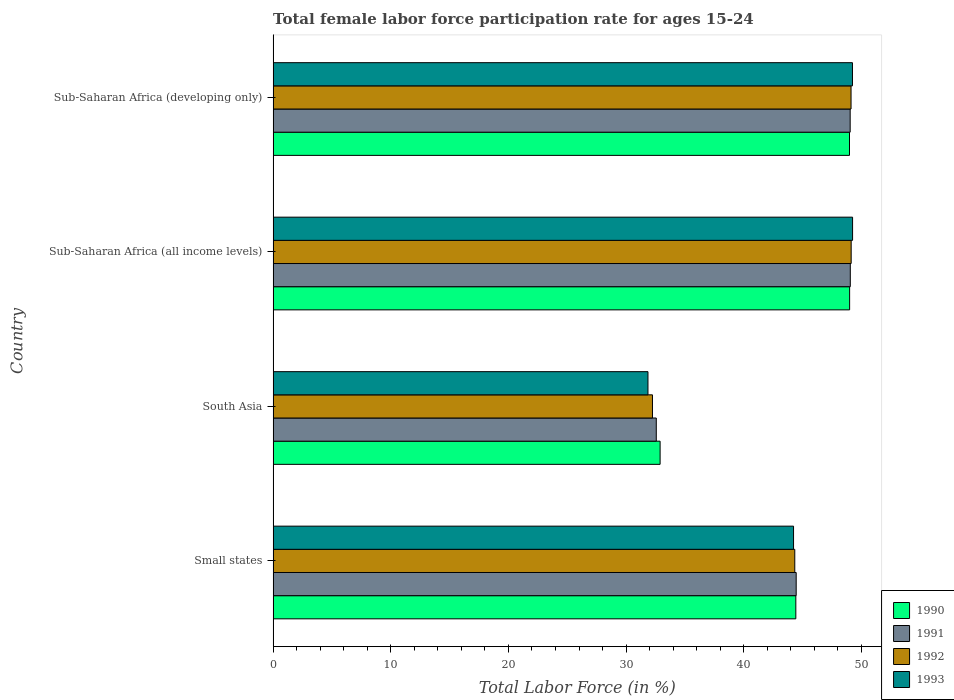How many different coloured bars are there?
Provide a succinct answer. 4. Are the number of bars on each tick of the Y-axis equal?
Your answer should be compact. Yes. How many bars are there on the 4th tick from the top?
Your response must be concise. 4. How many bars are there on the 2nd tick from the bottom?
Offer a very short reply. 4. What is the label of the 2nd group of bars from the top?
Provide a succinct answer. Sub-Saharan Africa (all income levels). What is the female labor force participation rate in 1990 in Sub-Saharan Africa (all income levels)?
Ensure brevity in your answer.  49. Across all countries, what is the maximum female labor force participation rate in 1993?
Your response must be concise. 49.25. Across all countries, what is the minimum female labor force participation rate in 1990?
Make the answer very short. 32.89. In which country was the female labor force participation rate in 1990 maximum?
Provide a succinct answer. Sub-Saharan Africa (all income levels). In which country was the female labor force participation rate in 1991 minimum?
Ensure brevity in your answer.  South Asia. What is the total female labor force participation rate in 1990 in the graph?
Your answer should be compact. 175.32. What is the difference between the female labor force participation rate in 1992 in South Asia and that in Sub-Saharan Africa (all income levels)?
Your response must be concise. -16.89. What is the difference between the female labor force participation rate in 1991 in Sub-Saharan Africa (developing only) and the female labor force participation rate in 1992 in Small states?
Make the answer very short. 4.71. What is the average female labor force participation rate in 1993 per country?
Offer a very short reply. 43.65. What is the difference between the female labor force participation rate in 1990 and female labor force participation rate in 1993 in Small states?
Your answer should be compact. 0.19. What is the ratio of the female labor force participation rate in 1991 in South Asia to that in Sub-Saharan Africa (all income levels)?
Your response must be concise. 0.66. Is the female labor force participation rate in 1993 in Sub-Saharan Africa (all income levels) less than that in Sub-Saharan Africa (developing only)?
Your response must be concise. No. Is the difference between the female labor force participation rate in 1990 in Small states and Sub-Saharan Africa (all income levels) greater than the difference between the female labor force participation rate in 1993 in Small states and Sub-Saharan Africa (all income levels)?
Make the answer very short. Yes. What is the difference between the highest and the second highest female labor force participation rate in 1990?
Offer a terse response. 0.01. What is the difference between the highest and the lowest female labor force participation rate in 1991?
Offer a terse response. 16.49. Is the sum of the female labor force participation rate in 1990 in Sub-Saharan Africa (all income levels) and Sub-Saharan Africa (developing only) greater than the maximum female labor force participation rate in 1991 across all countries?
Your answer should be compact. Yes. Is it the case that in every country, the sum of the female labor force participation rate in 1992 and female labor force participation rate in 1993 is greater than the sum of female labor force participation rate in 1991 and female labor force participation rate in 1990?
Provide a short and direct response. No. How many bars are there?
Ensure brevity in your answer.  16. Are the values on the major ticks of X-axis written in scientific E-notation?
Provide a short and direct response. No. How are the legend labels stacked?
Your answer should be compact. Vertical. What is the title of the graph?
Your answer should be very brief. Total female labor force participation rate for ages 15-24. Does "2009" appear as one of the legend labels in the graph?
Provide a short and direct response. No. What is the label or title of the X-axis?
Keep it short and to the point. Total Labor Force (in %). What is the Total Labor Force (in %) in 1990 in Small states?
Your response must be concise. 44.43. What is the Total Labor Force (in %) in 1991 in Small states?
Give a very brief answer. 44.46. What is the Total Labor Force (in %) of 1992 in Small states?
Provide a short and direct response. 44.34. What is the Total Labor Force (in %) of 1993 in Small states?
Give a very brief answer. 44.24. What is the Total Labor Force (in %) in 1990 in South Asia?
Offer a very short reply. 32.89. What is the Total Labor Force (in %) in 1991 in South Asia?
Keep it short and to the point. 32.57. What is the Total Labor Force (in %) in 1992 in South Asia?
Give a very brief answer. 32.24. What is the Total Labor Force (in %) in 1993 in South Asia?
Your answer should be very brief. 31.86. What is the Total Labor Force (in %) of 1990 in Sub-Saharan Africa (all income levels)?
Offer a very short reply. 49. What is the Total Labor Force (in %) of 1991 in Sub-Saharan Africa (all income levels)?
Provide a short and direct response. 49.06. What is the Total Labor Force (in %) in 1992 in Sub-Saharan Africa (all income levels)?
Your answer should be very brief. 49.13. What is the Total Labor Force (in %) of 1993 in Sub-Saharan Africa (all income levels)?
Give a very brief answer. 49.25. What is the Total Labor Force (in %) in 1990 in Sub-Saharan Africa (developing only)?
Your answer should be compact. 48.99. What is the Total Labor Force (in %) in 1991 in Sub-Saharan Africa (developing only)?
Keep it short and to the point. 49.05. What is the Total Labor Force (in %) in 1992 in Sub-Saharan Africa (developing only)?
Make the answer very short. 49.12. What is the Total Labor Force (in %) of 1993 in Sub-Saharan Africa (developing only)?
Your answer should be very brief. 49.24. Across all countries, what is the maximum Total Labor Force (in %) in 1990?
Your response must be concise. 49. Across all countries, what is the maximum Total Labor Force (in %) of 1991?
Your answer should be compact. 49.06. Across all countries, what is the maximum Total Labor Force (in %) of 1992?
Provide a short and direct response. 49.13. Across all countries, what is the maximum Total Labor Force (in %) in 1993?
Give a very brief answer. 49.25. Across all countries, what is the minimum Total Labor Force (in %) of 1990?
Make the answer very short. 32.89. Across all countries, what is the minimum Total Labor Force (in %) of 1991?
Provide a succinct answer. 32.57. Across all countries, what is the minimum Total Labor Force (in %) in 1992?
Give a very brief answer. 32.24. Across all countries, what is the minimum Total Labor Force (in %) of 1993?
Your answer should be compact. 31.86. What is the total Total Labor Force (in %) in 1990 in the graph?
Your answer should be compact. 175.32. What is the total Total Labor Force (in %) in 1991 in the graph?
Give a very brief answer. 175.14. What is the total Total Labor Force (in %) of 1992 in the graph?
Your answer should be compact. 174.84. What is the total Total Labor Force (in %) of 1993 in the graph?
Your response must be concise. 174.59. What is the difference between the Total Labor Force (in %) in 1990 in Small states and that in South Asia?
Give a very brief answer. 11.54. What is the difference between the Total Labor Force (in %) of 1991 in Small states and that in South Asia?
Offer a terse response. 11.89. What is the difference between the Total Labor Force (in %) in 1992 in Small states and that in South Asia?
Your answer should be compact. 12.1. What is the difference between the Total Labor Force (in %) in 1993 in Small states and that in South Asia?
Make the answer very short. 12.37. What is the difference between the Total Labor Force (in %) of 1990 in Small states and that in Sub-Saharan Africa (all income levels)?
Give a very brief answer. -4.57. What is the difference between the Total Labor Force (in %) in 1991 in Small states and that in Sub-Saharan Africa (all income levels)?
Your answer should be compact. -4.6. What is the difference between the Total Labor Force (in %) of 1992 in Small states and that in Sub-Saharan Africa (all income levels)?
Provide a short and direct response. -4.79. What is the difference between the Total Labor Force (in %) in 1993 in Small states and that in Sub-Saharan Africa (all income levels)?
Give a very brief answer. -5.02. What is the difference between the Total Labor Force (in %) of 1990 in Small states and that in Sub-Saharan Africa (developing only)?
Your answer should be compact. -4.56. What is the difference between the Total Labor Force (in %) of 1991 in Small states and that in Sub-Saharan Africa (developing only)?
Offer a very short reply. -4.59. What is the difference between the Total Labor Force (in %) in 1992 in Small states and that in Sub-Saharan Africa (developing only)?
Offer a very short reply. -4.78. What is the difference between the Total Labor Force (in %) in 1993 in Small states and that in Sub-Saharan Africa (developing only)?
Your answer should be very brief. -5.01. What is the difference between the Total Labor Force (in %) of 1990 in South Asia and that in Sub-Saharan Africa (all income levels)?
Keep it short and to the point. -16.11. What is the difference between the Total Labor Force (in %) of 1991 in South Asia and that in Sub-Saharan Africa (all income levels)?
Your answer should be compact. -16.49. What is the difference between the Total Labor Force (in %) in 1992 in South Asia and that in Sub-Saharan Africa (all income levels)?
Keep it short and to the point. -16.89. What is the difference between the Total Labor Force (in %) in 1993 in South Asia and that in Sub-Saharan Africa (all income levels)?
Offer a very short reply. -17.39. What is the difference between the Total Labor Force (in %) of 1990 in South Asia and that in Sub-Saharan Africa (developing only)?
Ensure brevity in your answer.  -16.1. What is the difference between the Total Labor Force (in %) of 1991 in South Asia and that in Sub-Saharan Africa (developing only)?
Provide a short and direct response. -16.48. What is the difference between the Total Labor Force (in %) of 1992 in South Asia and that in Sub-Saharan Africa (developing only)?
Ensure brevity in your answer.  -16.88. What is the difference between the Total Labor Force (in %) in 1993 in South Asia and that in Sub-Saharan Africa (developing only)?
Give a very brief answer. -17.38. What is the difference between the Total Labor Force (in %) of 1990 in Sub-Saharan Africa (all income levels) and that in Sub-Saharan Africa (developing only)?
Your answer should be compact. 0.01. What is the difference between the Total Labor Force (in %) in 1991 in Sub-Saharan Africa (all income levels) and that in Sub-Saharan Africa (developing only)?
Keep it short and to the point. 0.01. What is the difference between the Total Labor Force (in %) in 1992 in Sub-Saharan Africa (all income levels) and that in Sub-Saharan Africa (developing only)?
Provide a succinct answer. 0.01. What is the difference between the Total Labor Force (in %) of 1993 in Sub-Saharan Africa (all income levels) and that in Sub-Saharan Africa (developing only)?
Provide a short and direct response. 0.01. What is the difference between the Total Labor Force (in %) in 1990 in Small states and the Total Labor Force (in %) in 1991 in South Asia?
Provide a succinct answer. 11.86. What is the difference between the Total Labor Force (in %) of 1990 in Small states and the Total Labor Force (in %) of 1992 in South Asia?
Your answer should be compact. 12.19. What is the difference between the Total Labor Force (in %) of 1990 in Small states and the Total Labor Force (in %) of 1993 in South Asia?
Provide a succinct answer. 12.57. What is the difference between the Total Labor Force (in %) in 1991 in Small states and the Total Labor Force (in %) in 1992 in South Asia?
Provide a succinct answer. 12.22. What is the difference between the Total Labor Force (in %) in 1991 in Small states and the Total Labor Force (in %) in 1993 in South Asia?
Provide a short and direct response. 12.6. What is the difference between the Total Labor Force (in %) in 1992 in Small states and the Total Labor Force (in %) in 1993 in South Asia?
Offer a very short reply. 12.48. What is the difference between the Total Labor Force (in %) in 1990 in Small states and the Total Labor Force (in %) in 1991 in Sub-Saharan Africa (all income levels)?
Provide a succinct answer. -4.63. What is the difference between the Total Labor Force (in %) in 1990 in Small states and the Total Labor Force (in %) in 1992 in Sub-Saharan Africa (all income levels)?
Give a very brief answer. -4.7. What is the difference between the Total Labor Force (in %) in 1990 in Small states and the Total Labor Force (in %) in 1993 in Sub-Saharan Africa (all income levels)?
Your answer should be compact. -4.82. What is the difference between the Total Labor Force (in %) in 1991 in Small states and the Total Labor Force (in %) in 1992 in Sub-Saharan Africa (all income levels)?
Give a very brief answer. -4.67. What is the difference between the Total Labor Force (in %) of 1991 in Small states and the Total Labor Force (in %) of 1993 in Sub-Saharan Africa (all income levels)?
Give a very brief answer. -4.79. What is the difference between the Total Labor Force (in %) of 1992 in Small states and the Total Labor Force (in %) of 1993 in Sub-Saharan Africa (all income levels)?
Give a very brief answer. -4.91. What is the difference between the Total Labor Force (in %) of 1990 in Small states and the Total Labor Force (in %) of 1991 in Sub-Saharan Africa (developing only)?
Ensure brevity in your answer.  -4.62. What is the difference between the Total Labor Force (in %) of 1990 in Small states and the Total Labor Force (in %) of 1992 in Sub-Saharan Africa (developing only)?
Your response must be concise. -4.69. What is the difference between the Total Labor Force (in %) of 1990 in Small states and the Total Labor Force (in %) of 1993 in Sub-Saharan Africa (developing only)?
Offer a very short reply. -4.81. What is the difference between the Total Labor Force (in %) of 1991 in Small states and the Total Labor Force (in %) of 1992 in Sub-Saharan Africa (developing only)?
Keep it short and to the point. -4.66. What is the difference between the Total Labor Force (in %) in 1991 in Small states and the Total Labor Force (in %) in 1993 in Sub-Saharan Africa (developing only)?
Provide a succinct answer. -4.78. What is the difference between the Total Labor Force (in %) in 1992 in Small states and the Total Labor Force (in %) in 1993 in Sub-Saharan Africa (developing only)?
Give a very brief answer. -4.9. What is the difference between the Total Labor Force (in %) in 1990 in South Asia and the Total Labor Force (in %) in 1991 in Sub-Saharan Africa (all income levels)?
Your answer should be very brief. -16.17. What is the difference between the Total Labor Force (in %) of 1990 in South Asia and the Total Labor Force (in %) of 1992 in Sub-Saharan Africa (all income levels)?
Your answer should be compact. -16.24. What is the difference between the Total Labor Force (in %) in 1990 in South Asia and the Total Labor Force (in %) in 1993 in Sub-Saharan Africa (all income levels)?
Your answer should be very brief. -16.36. What is the difference between the Total Labor Force (in %) of 1991 in South Asia and the Total Labor Force (in %) of 1992 in Sub-Saharan Africa (all income levels)?
Provide a short and direct response. -16.56. What is the difference between the Total Labor Force (in %) in 1991 in South Asia and the Total Labor Force (in %) in 1993 in Sub-Saharan Africa (all income levels)?
Give a very brief answer. -16.68. What is the difference between the Total Labor Force (in %) in 1992 in South Asia and the Total Labor Force (in %) in 1993 in Sub-Saharan Africa (all income levels)?
Provide a succinct answer. -17.01. What is the difference between the Total Labor Force (in %) in 1990 in South Asia and the Total Labor Force (in %) in 1991 in Sub-Saharan Africa (developing only)?
Ensure brevity in your answer.  -16.16. What is the difference between the Total Labor Force (in %) of 1990 in South Asia and the Total Labor Force (in %) of 1992 in Sub-Saharan Africa (developing only)?
Give a very brief answer. -16.23. What is the difference between the Total Labor Force (in %) in 1990 in South Asia and the Total Labor Force (in %) in 1993 in Sub-Saharan Africa (developing only)?
Make the answer very short. -16.35. What is the difference between the Total Labor Force (in %) of 1991 in South Asia and the Total Labor Force (in %) of 1992 in Sub-Saharan Africa (developing only)?
Your answer should be compact. -16.55. What is the difference between the Total Labor Force (in %) in 1991 in South Asia and the Total Labor Force (in %) in 1993 in Sub-Saharan Africa (developing only)?
Your response must be concise. -16.68. What is the difference between the Total Labor Force (in %) of 1992 in South Asia and the Total Labor Force (in %) of 1993 in Sub-Saharan Africa (developing only)?
Make the answer very short. -17. What is the difference between the Total Labor Force (in %) in 1990 in Sub-Saharan Africa (all income levels) and the Total Labor Force (in %) in 1991 in Sub-Saharan Africa (developing only)?
Keep it short and to the point. -0.05. What is the difference between the Total Labor Force (in %) of 1990 in Sub-Saharan Africa (all income levels) and the Total Labor Force (in %) of 1992 in Sub-Saharan Africa (developing only)?
Keep it short and to the point. -0.12. What is the difference between the Total Labor Force (in %) of 1990 in Sub-Saharan Africa (all income levels) and the Total Labor Force (in %) of 1993 in Sub-Saharan Africa (developing only)?
Provide a succinct answer. -0.24. What is the difference between the Total Labor Force (in %) of 1991 in Sub-Saharan Africa (all income levels) and the Total Labor Force (in %) of 1992 in Sub-Saharan Africa (developing only)?
Offer a terse response. -0.06. What is the difference between the Total Labor Force (in %) of 1991 in Sub-Saharan Africa (all income levels) and the Total Labor Force (in %) of 1993 in Sub-Saharan Africa (developing only)?
Offer a terse response. -0.18. What is the difference between the Total Labor Force (in %) in 1992 in Sub-Saharan Africa (all income levels) and the Total Labor Force (in %) in 1993 in Sub-Saharan Africa (developing only)?
Give a very brief answer. -0.11. What is the average Total Labor Force (in %) in 1990 per country?
Make the answer very short. 43.83. What is the average Total Labor Force (in %) of 1991 per country?
Provide a short and direct response. 43.78. What is the average Total Labor Force (in %) of 1992 per country?
Make the answer very short. 43.71. What is the average Total Labor Force (in %) of 1993 per country?
Ensure brevity in your answer.  43.65. What is the difference between the Total Labor Force (in %) in 1990 and Total Labor Force (in %) in 1991 in Small states?
Provide a short and direct response. -0.03. What is the difference between the Total Labor Force (in %) of 1990 and Total Labor Force (in %) of 1992 in Small states?
Give a very brief answer. 0.09. What is the difference between the Total Labor Force (in %) in 1990 and Total Labor Force (in %) in 1993 in Small states?
Keep it short and to the point. 0.19. What is the difference between the Total Labor Force (in %) in 1991 and Total Labor Force (in %) in 1992 in Small states?
Provide a succinct answer. 0.12. What is the difference between the Total Labor Force (in %) in 1991 and Total Labor Force (in %) in 1993 in Small states?
Your answer should be compact. 0.22. What is the difference between the Total Labor Force (in %) of 1992 and Total Labor Force (in %) of 1993 in Small states?
Your answer should be very brief. 0.1. What is the difference between the Total Labor Force (in %) of 1990 and Total Labor Force (in %) of 1991 in South Asia?
Ensure brevity in your answer.  0.32. What is the difference between the Total Labor Force (in %) of 1990 and Total Labor Force (in %) of 1992 in South Asia?
Provide a short and direct response. 0.65. What is the difference between the Total Labor Force (in %) in 1990 and Total Labor Force (in %) in 1993 in South Asia?
Your response must be concise. 1.03. What is the difference between the Total Labor Force (in %) of 1991 and Total Labor Force (in %) of 1992 in South Asia?
Your response must be concise. 0.32. What is the difference between the Total Labor Force (in %) in 1991 and Total Labor Force (in %) in 1993 in South Asia?
Your answer should be compact. 0.71. What is the difference between the Total Labor Force (in %) in 1992 and Total Labor Force (in %) in 1993 in South Asia?
Your answer should be very brief. 0.38. What is the difference between the Total Labor Force (in %) in 1990 and Total Labor Force (in %) in 1991 in Sub-Saharan Africa (all income levels)?
Provide a short and direct response. -0.06. What is the difference between the Total Labor Force (in %) in 1990 and Total Labor Force (in %) in 1992 in Sub-Saharan Africa (all income levels)?
Your answer should be very brief. -0.13. What is the difference between the Total Labor Force (in %) in 1990 and Total Labor Force (in %) in 1993 in Sub-Saharan Africa (all income levels)?
Keep it short and to the point. -0.25. What is the difference between the Total Labor Force (in %) of 1991 and Total Labor Force (in %) of 1992 in Sub-Saharan Africa (all income levels)?
Provide a succinct answer. -0.07. What is the difference between the Total Labor Force (in %) of 1991 and Total Labor Force (in %) of 1993 in Sub-Saharan Africa (all income levels)?
Provide a short and direct response. -0.19. What is the difference between the Total Labor Force (in %) in 1992 and Total Labor Force (in %) in 1993 in Sub-Saharan Africa (all income levels)?
Your response must be concise. -0.12. What is the difference between the Total Labor Force (in %) of 1990 and Total Labor Force (in %) of 1991 in Sub-Saharan Africa (developing only)?
Ensure brevity in your answer.  -0.06. What is the difference between the Total Labor Force (in %) of 1990 and Total Labor Force (in %) of 1992 in Sub-Saharan Africa (developing only)?
Keep it short and to the point. -0.13. What is the difference between the Total Labor Force (in %) in 1990 and Total Labor Force (in %) in 1993 in Sub-Saharan Africa (developing only)?
Make the answer very short. -0.25. What is the difference between the Total Labor Force (in %) in 1991 and Total Labor Force (in %) in 1992 in Sub-Saharan Africa (developing only)?
Your response must be concise. -0.07. What is the difference between the Total Labor Force (in %) in 1991 and Total Labor Force (in %) in 1993 in Sub-Saharan Africa (developing only)?
Ensure brevity in your answer.  -0.2. What is the difference between the Total Labor Force (in %) of 1992 and Total Labor Force (in %) of 1993 in Sub-Saharan Africa (developing only)?
Provide a succinct answer. -0.12. What is the ratio of the Total Labor Force (in %) in 1990 in Small states to that in South Asia?
Provide a short and direct response. 1.35. What is the ratio of the Total Labor Force (in %) of 1991 in Small states to that in South Asia?
Offer a very short reply. 1.37. What is the ratio of the Total Labor Force (in %) in 1992 in Small states to that in South Asia?
Ensure brevity in your answer.  1.38. What is the ratio of the Total Labor Force (in %) of 1993 in Small states to that in South Asia?
Make the answer very short. 1.39. What is the ratio of the Total Labor Force (in %) of 1990 in Small states to that in Sub-Saharan Africa (all income levels)?
Your answer should be compact. 0.91. What is the ratio of the Total Labor Force (in %) of 1991 in Small states to that in Sub-Saharan Africa (all income levels)?
Your response must be concise. 0.91. What is the ratio of the Total Labor Force (in %) in 1992 in Small states to that in Sub-Saharan Africa (all income levels)?
Keep it short and to the point. 0.9. What is the ratio of the Total Labor Force (in %) of 1993 in Small states to that in Sub-Saharan Africa (all income levels)?
Make the answer very short. 0.9. What is the ratio of the Total Labor Force (in %) of 1990 in Small states to that in Sub-Saharan Africa (developing only)?
Make the answer very short. 0.91. What is the ratio of the Total Labor Force (in %) of 1991 in Small states to that in Sub-Saharan Africa (developing only)?
Provide a succinct answer. 0.91. What is the ratio of the Total Labor Force (in %) of 1992 in Small states to that in Sub-Saharan Africa (developing only)?
Provide a short and direct response. 0.9. What is the ratio of the Total Labor Force (in %) of 1993 in Small states to that in Sub-Saharan Africa (developing only)?
Your answer should be compact. 0.9. What is the ratio of the Total Labor Force (in %) of 1990 in South Asia to that in Sub-Saharan Africa (all income levels)?
Keep it short and to the point. 0.67. What is the ratio of the Total Labor Force (in %) of 1991 in South Asia to that in Sub-Saharan Africa (all income levels)?
Make the answer very short. 0.66. What is the ratio of the Total Labor Force (in %) of 1992 in South Asia to that in Sub-Saharan Africa (all income levels)?
Ensure brevity in your answer.  0.66. What is the ratio of the Total Labor Force (in %) of 1993 in South Asia to that in Sub-Saharan Africa (all income levels)?
Provide a succinct answer. 0.65. What is the ratio of the Total Labor Force (in %) in 1990 in South Asia to that in Sub-Saharan Africa (developing only)?
Provide a succinct answer. 0.67. What is the ratio of the Total Labor Force (in %) of 1991 in South Asia to that in Sub-Saharan Africa (developing only)?
Offer a very short reply. 0.66. What is the ratio of the Total Labor Force (in %) in 1992 in South Asia to that in Sub-Saharan Africa (developing only)?
Your answer should be very brief. 0.66. What is the ratio of the Total Labor Force (in %) of 1993 in South Asia to that in Sub-Saharan Africa (developing only)?
Your answer should be compact. 0.65. What is the ratio of the Total Labor Force (in %) in 1991 in Sub-Saharan Africa (all income levels) to that in Sub-Saharan Africa (developing only)?
Provide a succinct answer. 1. What is the ratio of the Total Labor Force (in %) of 1993 in Sub-Saharan Africa (all income levels) to that in Sub-Saharan Africa (developing only)?
Provide a succinct answer. 1. What is the difference between the highest and the second highest Total Labor Force (in %) in 1990?
Your answer should be very brief. 0.01. What is the difference between the highest and the second highest Total Labor Force (in %) of 1991?
Give a very brief answer. 0.01. What is the difference between the highest and the second highest Total Labor Force (in %) of 1992?
Provide a succinct answer. 0.01. What is the difference between the highest and the second highest Total Labor Force (in %) of 1993?
Offer a very short reply. 0.01. What is the difference between the highest and the lowest Total Labor Force (in %) of 1990?
Your answer should be compact. 16.11. What is the difference between the highest and the lowest Total Labor Force (in %) in 1991?
Offer a terse response. 16.49. What is the difference between the highest and the lowest Total Labor Force (in %) of 1992?
Ensure brevity in your answer.  16.89. What is the difference between the highest and the lowest Total Labor Force (in %) of 1993?
Your answer should be very brief. 17.39. 